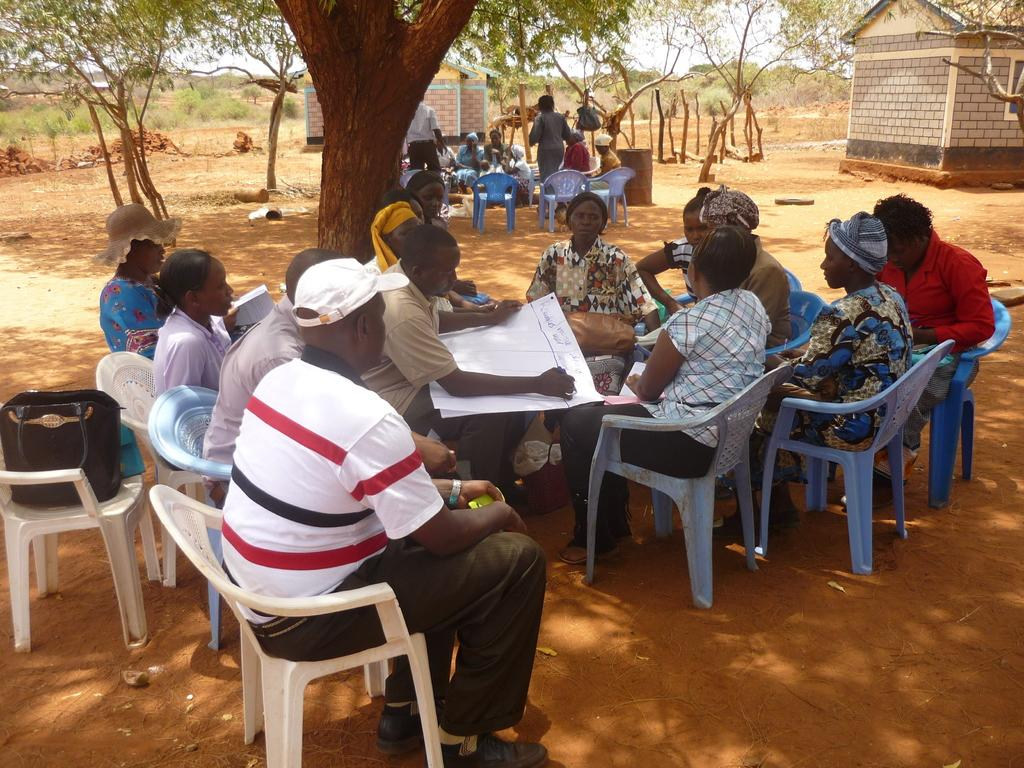What is happening in the image? There is a group of people in the image. How are the people positioned in the image? The people are sitting on chairs. What can be seen in the background of the image? There are trees and houses visible in the background of the image. What type of acoustics can be heard in the image? There is no information about sound or acoustics in the image, so it cannot be determined from the image. 